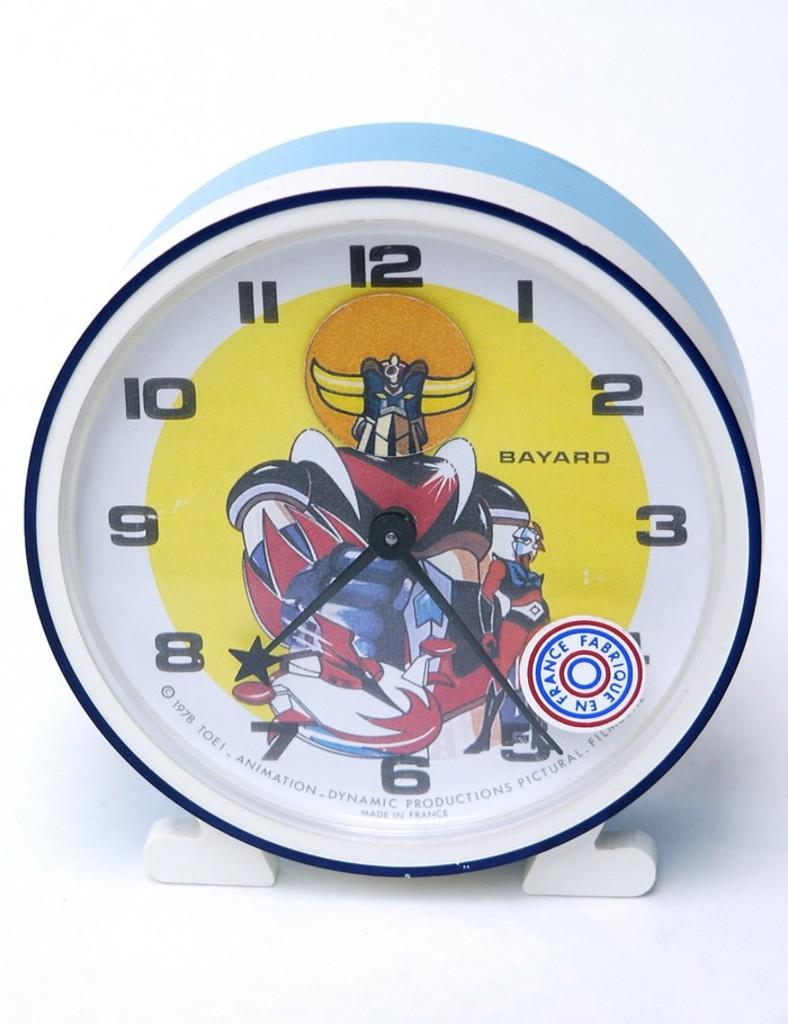<image>
Present a compact description of the photo's key features. A small clock that was made in France. 